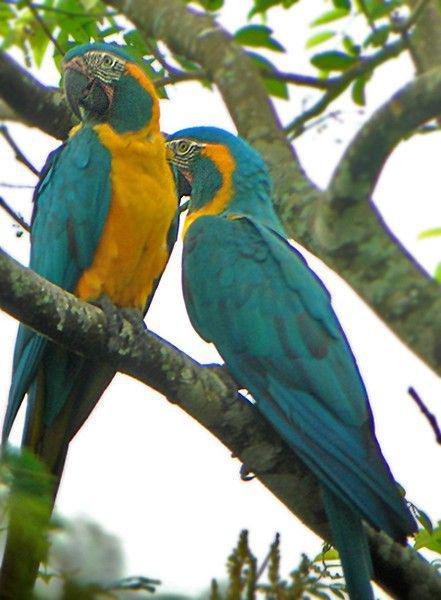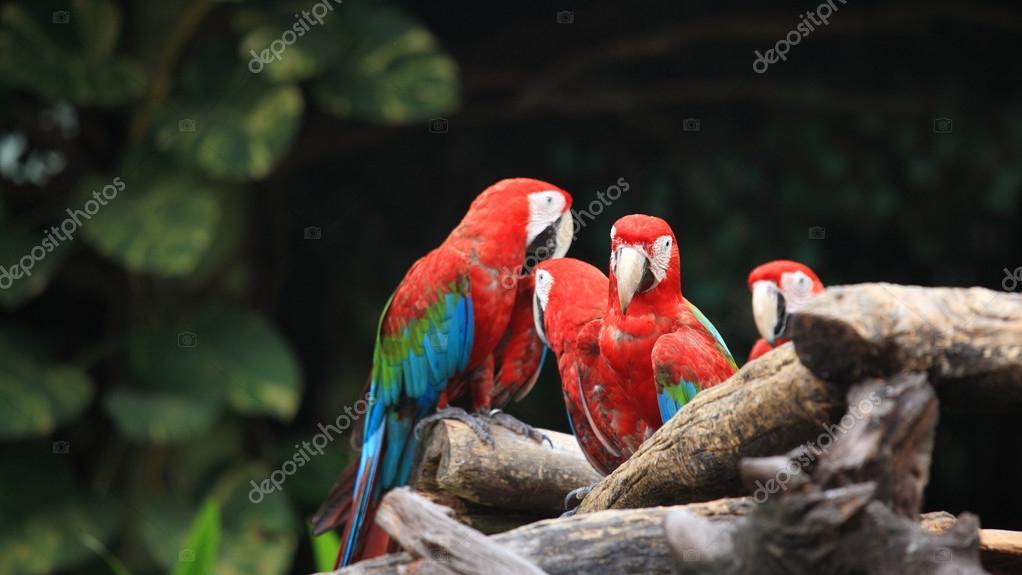The first image is the image on the left, the second image is the image on the right. For the images shown, is this caption "There are two birds in the image on the right." true? Answer yes or no. No. 